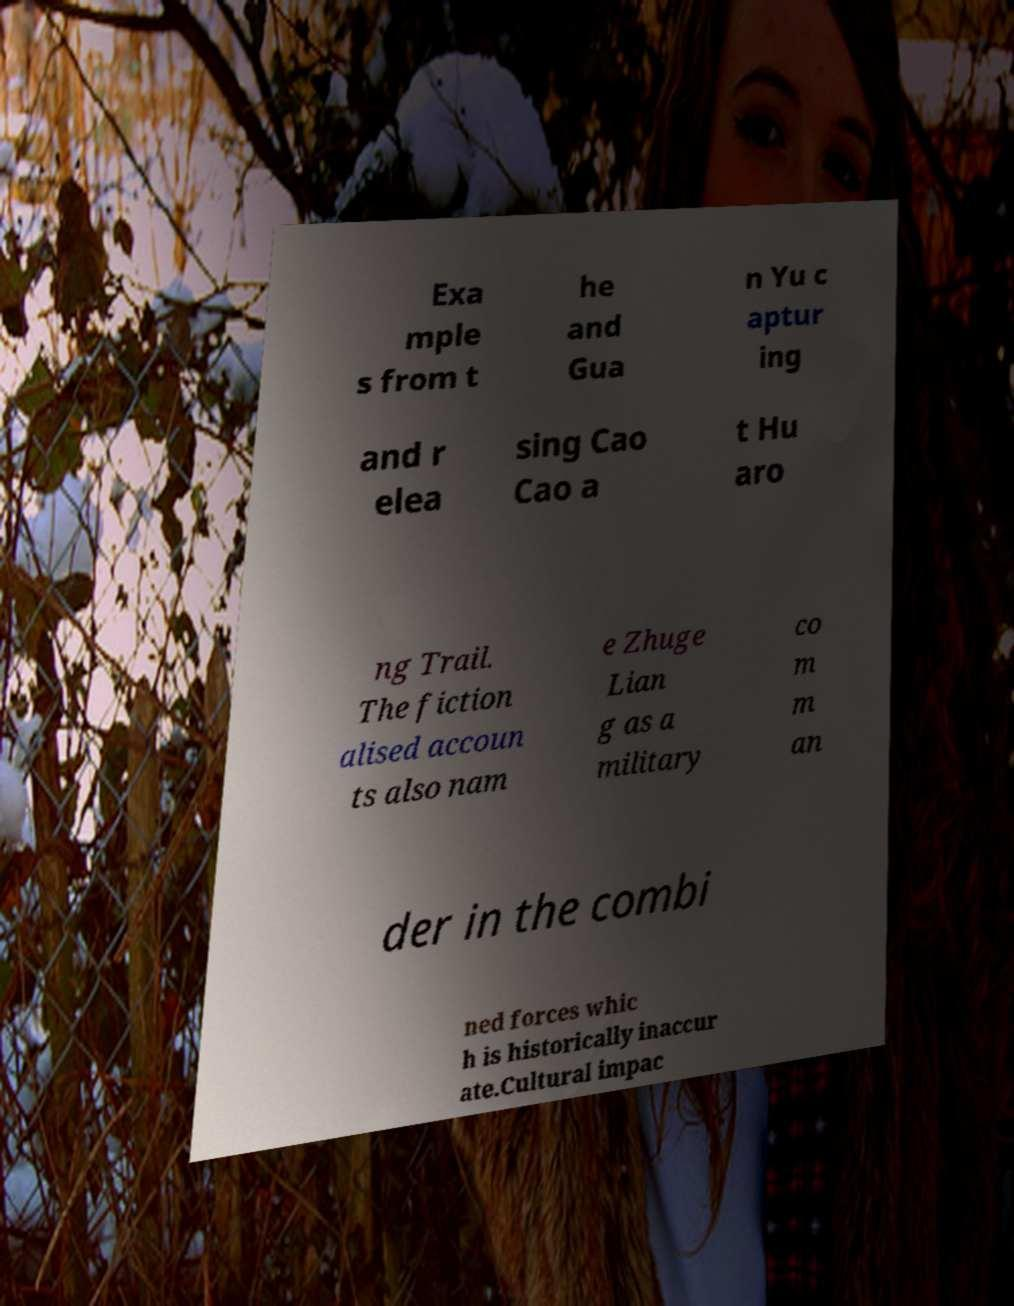Could you extract and type out the text from this image? Exa mple s from t he and Gua n Yu c aptur ing and r elea sing Cao Cao a t Hu aro ng Trail. The fiction alised accoun ts also nam e Zhuge Lian g as a military co m m an der in the combi ned forces whic h is historically inaccur ate.Cultural impac 